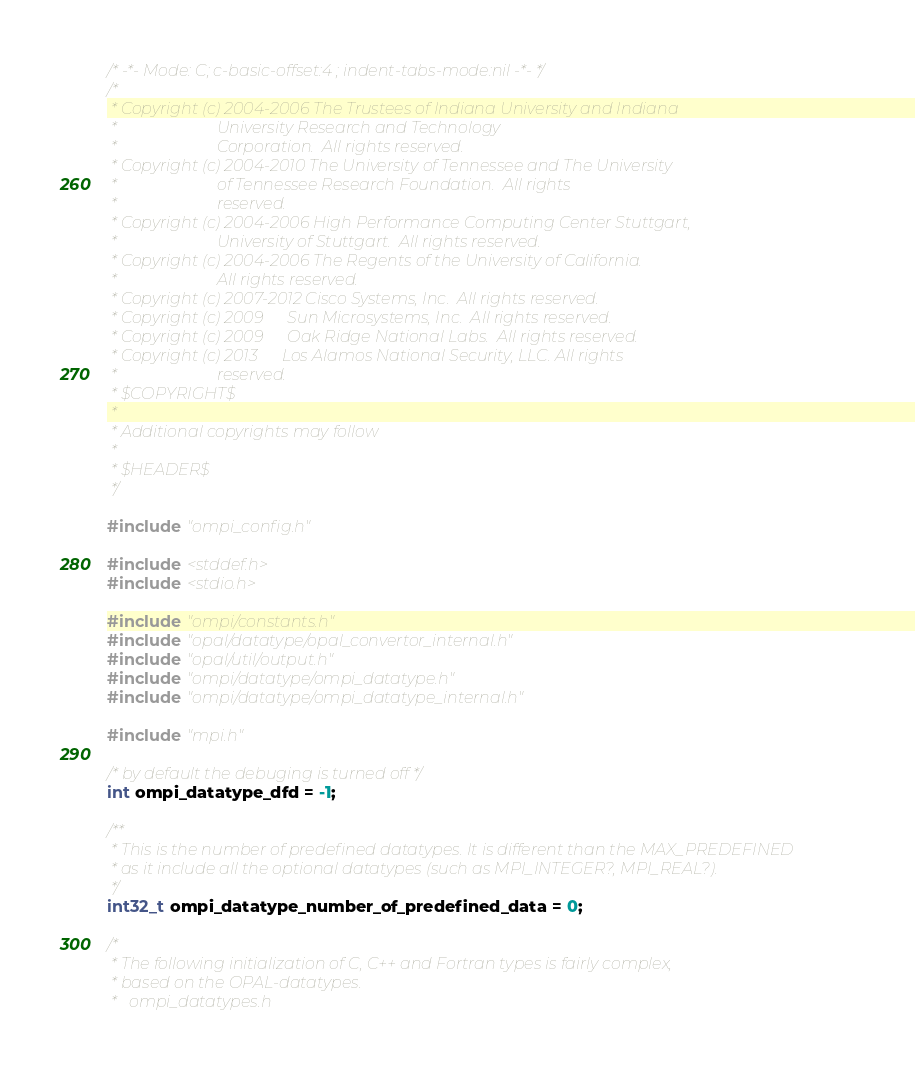<code> <loc_0><loc_0><loc_500><loc_500><_C_>/* -*- Mode: C; c-basic-offset:4 ; indent-tabs-mode:nil -*- */
/*
 * Copyright (c) 2004-2006 The Trustees of Indiana University and Indiana
 *                         University Research and Technology
 *                         Corporation.  All rights reserved.
 * Copyright (c) 2004-2010 The University of Tennessee and The University
 *                         of Tennessee Research Foundation.  All rights
 *                         reserved.
 * Copyright (c) 2004-2006 High Performance Computing Center Stuttgart,
 *                         University of Stuttgart.  All rights reserved.
 * Copyright (c) 2004-2006 The Regents of the University of California.
 *                         All rights reserved.
 * Copyright (c) 2007-2012 Cisco Systems, Inc.  All rights reserved.
 * Copyright (c) 2009      Sun Microsystems, Inc.  All rights reserved.
 * Copyright (c) 2009      Oak Ridge National Labs.  All rights reserved.
 * Copyright (c) 2013      Los Alamos National Security, LLC. All rights
 *                         reserved.
 * $COPYRIGHT$
 *
 * Additional copyrights may follow
 *
 * $HEADER$
 */

#include "ompi_config.h"

#include <stddef.h>
#include <stdio.h>

#include "ompi/constants.h"
#include "opal/datatype/opal_convertor_internal.h"
#include "opal/util/output.h"
#include "ompi/datatype/ompi_datatype.h"
#include "ompi/datatype/ompi_datatype_internal.h"

#include "mpi.h"

/* by default the debuging is turned off */
int ompi_datatype_dfd = -1;

/**
 * This is the number of predefined datatypes. It is different than the MAX_PREDEFINED
 * as it include all the optional datatypes (such as MPI_INTEGER?, MPI_REAL?).
 */
int32_t ompi_datatype_number_of_predefined_data = 0;

/*
 * The following initialization of C, C++ and Fortran types is fairly complex,
 * based on the OPAL-datatypes.
 *   ompi_datatypes.h</code> 